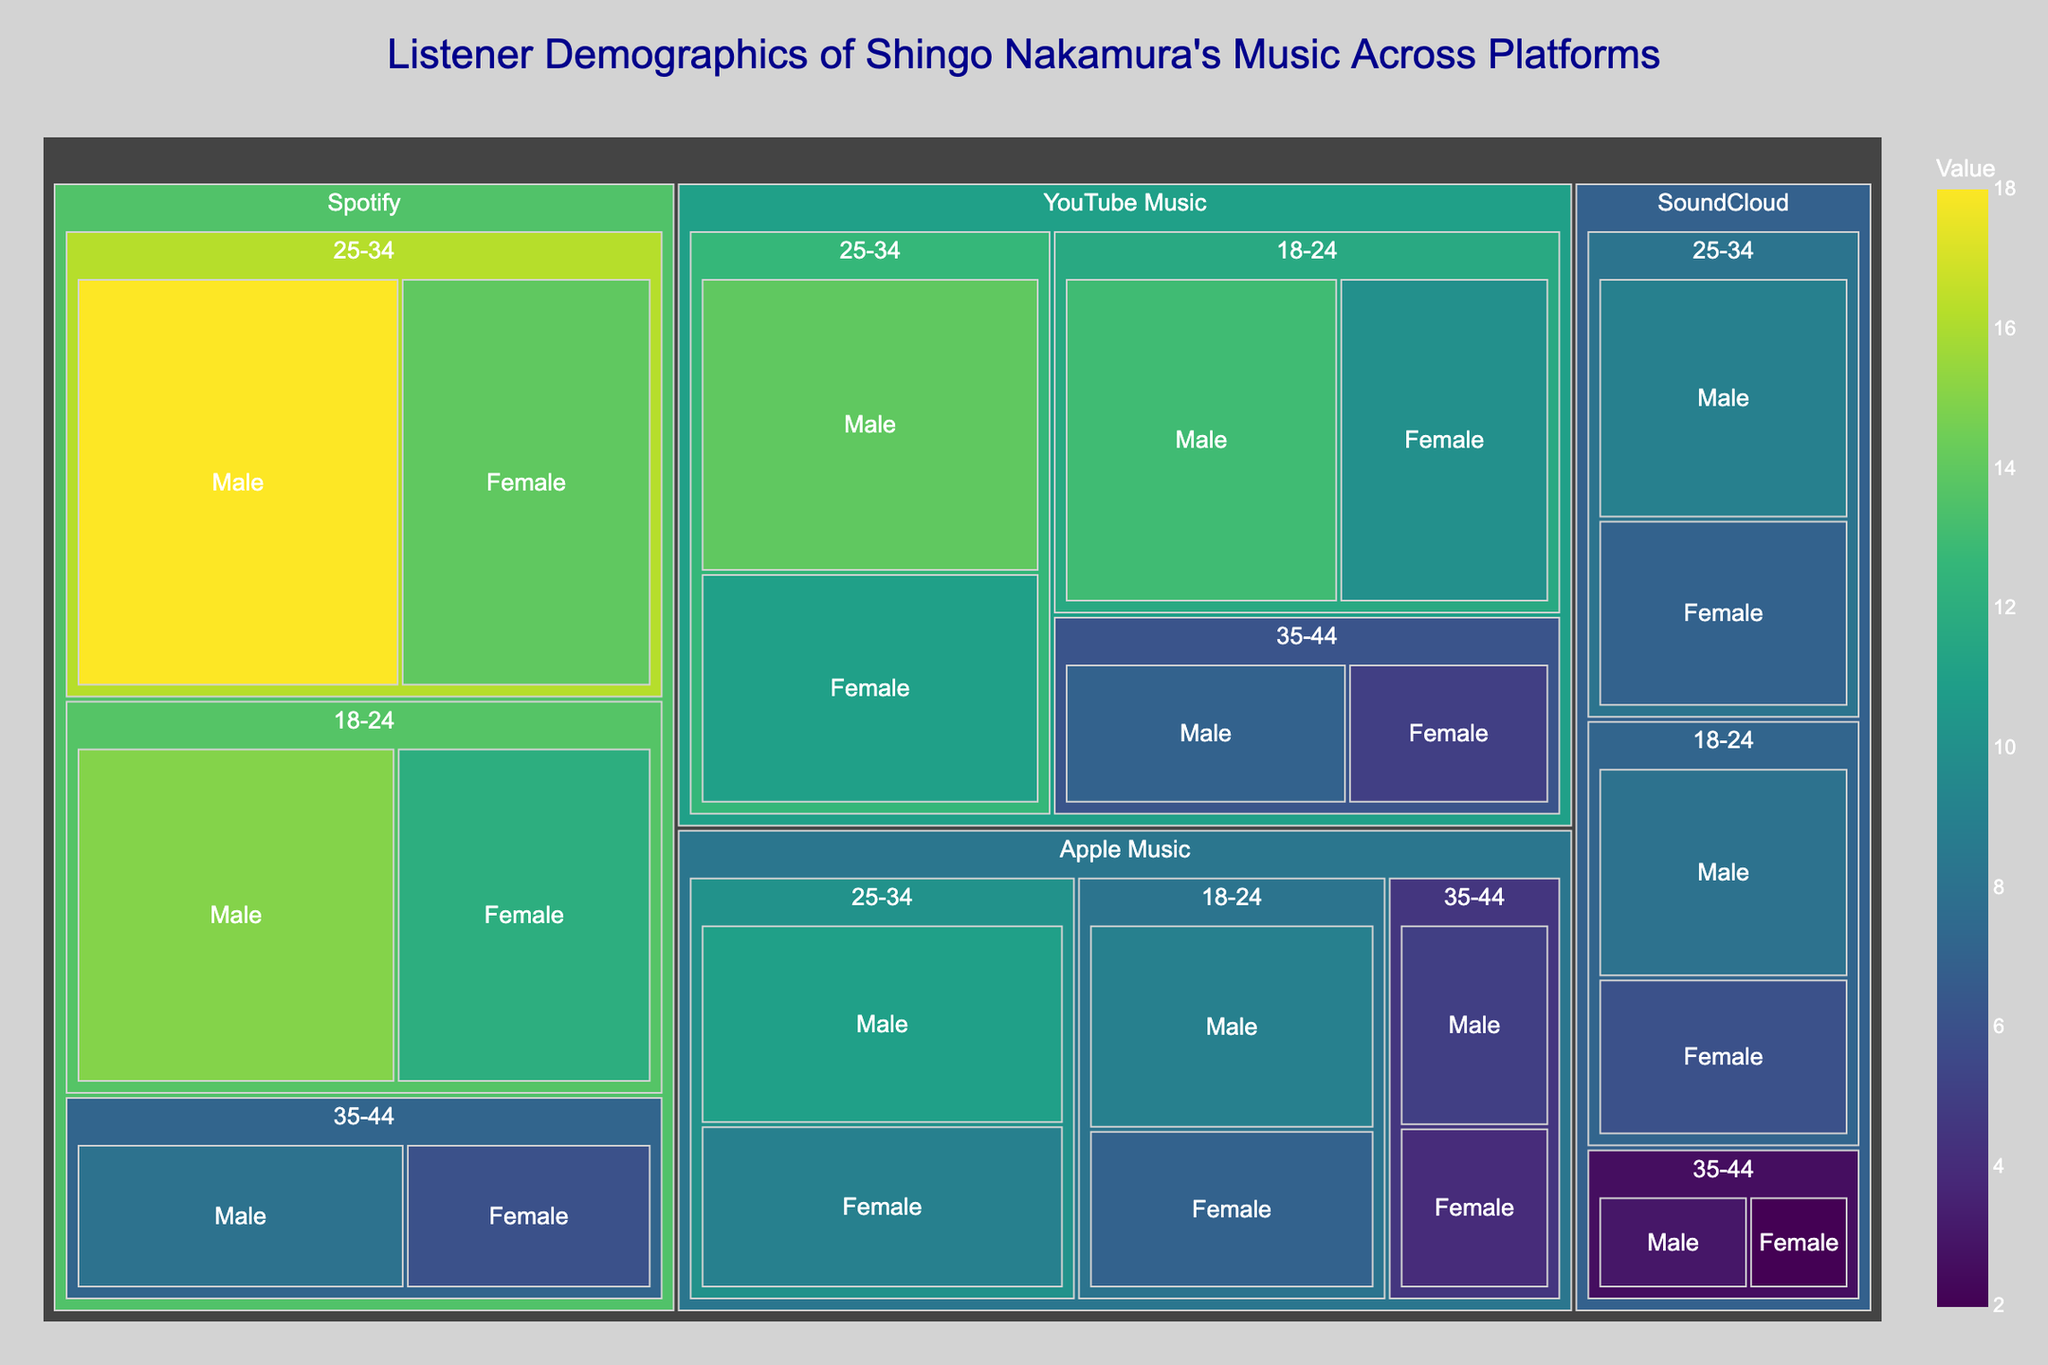What is the highest percentage of listeners in the 25-34 age group on Spotify? Identify the age group (25-34) and platform (Spotify), then find the highest percentage for that age group-platform combination. The percentages are 18% (Male) and 14% (Female); the highest is 18%.
Answer: 18% Which gender has a higher percentage in the 18-24 age group on YouTube Music? Look at the gender percentages within the 18-24 age group for YouTube Music. The percentages are 13% (Male) and 10% (Female); Male has a higher percentage.
Answer: Male What is the combined percentage of female listeners on Apple Music? Sum all percentages of female listeners on Apple Music: 7% (18-24), 9% (25-34), and 4% (35-44). The combined percentage is 7 + 9 + 4 = 20%.
Answer: 20% Across all platforms, which age group has the highest total percentage of listeners? Sum percentages for each age group across all platforms. The age groups' sums are (15+12+18+14+8+6) for Spotify, (9+7+11+9+5+4) for Apple Music, (13+10+14+11+7+5) for YouTube Music, and (8+6+9+7+3+2) for SoundCloud. The sums yield 73% (18-24), 83% (25-34), and 73% (35-44). The highest total is for the 25-34 age group.
Answer: 25-34 Which platform has the lowest percentage of listeners in the 35-44 age group? Compare the percentages for the platform's 35-44 age group: Spotify (8% + 6%), Apple Music (5% + 4%), YouTube Music (7% + 5%), and SoundCloud (3% + 2%). The lowest percentage is on SoundCloud with 3% + 2% = 5%.
Answer: SoundCloud Compare the percentage of male listeners aged 18-24 on SoundCloud to that on Apple Music. Which platform has a higher percentage? Compare Male (18-24) percentages for SoundCloud (8%) and Apple Music (9%). Apple Music has a higher percentage.
Answer: Apple Music What is the percentage difference between female listeners aged 25-34 on Spotify versus YouTube Music? Subtract the percentage of female listeners aged 25-34 on Spotify (14%) from that on YouTube Music (11%). The difference is 14 - 11 = 3%.
Answer: 3% Is the percentage of listeners aged 35-44 on all platforms higher or lower for males compared to females? Calculate total percentage for males in 35-44 across all platforms (8+5+7+3=23%) and females (6+4+5+2=17%). Compare the two sums; male percentage (23%) is higher than female percentage (17%).
Answer: Higher What is the largest single percentage share for any gender and age group on any platform? Identify the highest percentage in the dataset, considering all gender, age group, and platform combinations. The highest percentage found is 18% for males aged 25-34 on Spotify.
Answer: 18% Which age group has the largest female listener percentage on YouTube Music? Compare the female listener percentages within each age group on YouTube Music: 10% (18-24), 11% (25-34), and 5% (35-44). The largest female listener percentage is 11% in the 25-34 age group.
Answer: 25-34 